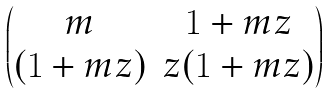Convert formula to latex. <formula><loc_0><loc_0><loc_500><loc_500>\begin{pmatrix} m & 1 + m z \\ ( 1 + m z ) & z ( 1 + m z ) \end{pmatrix}</formula> 